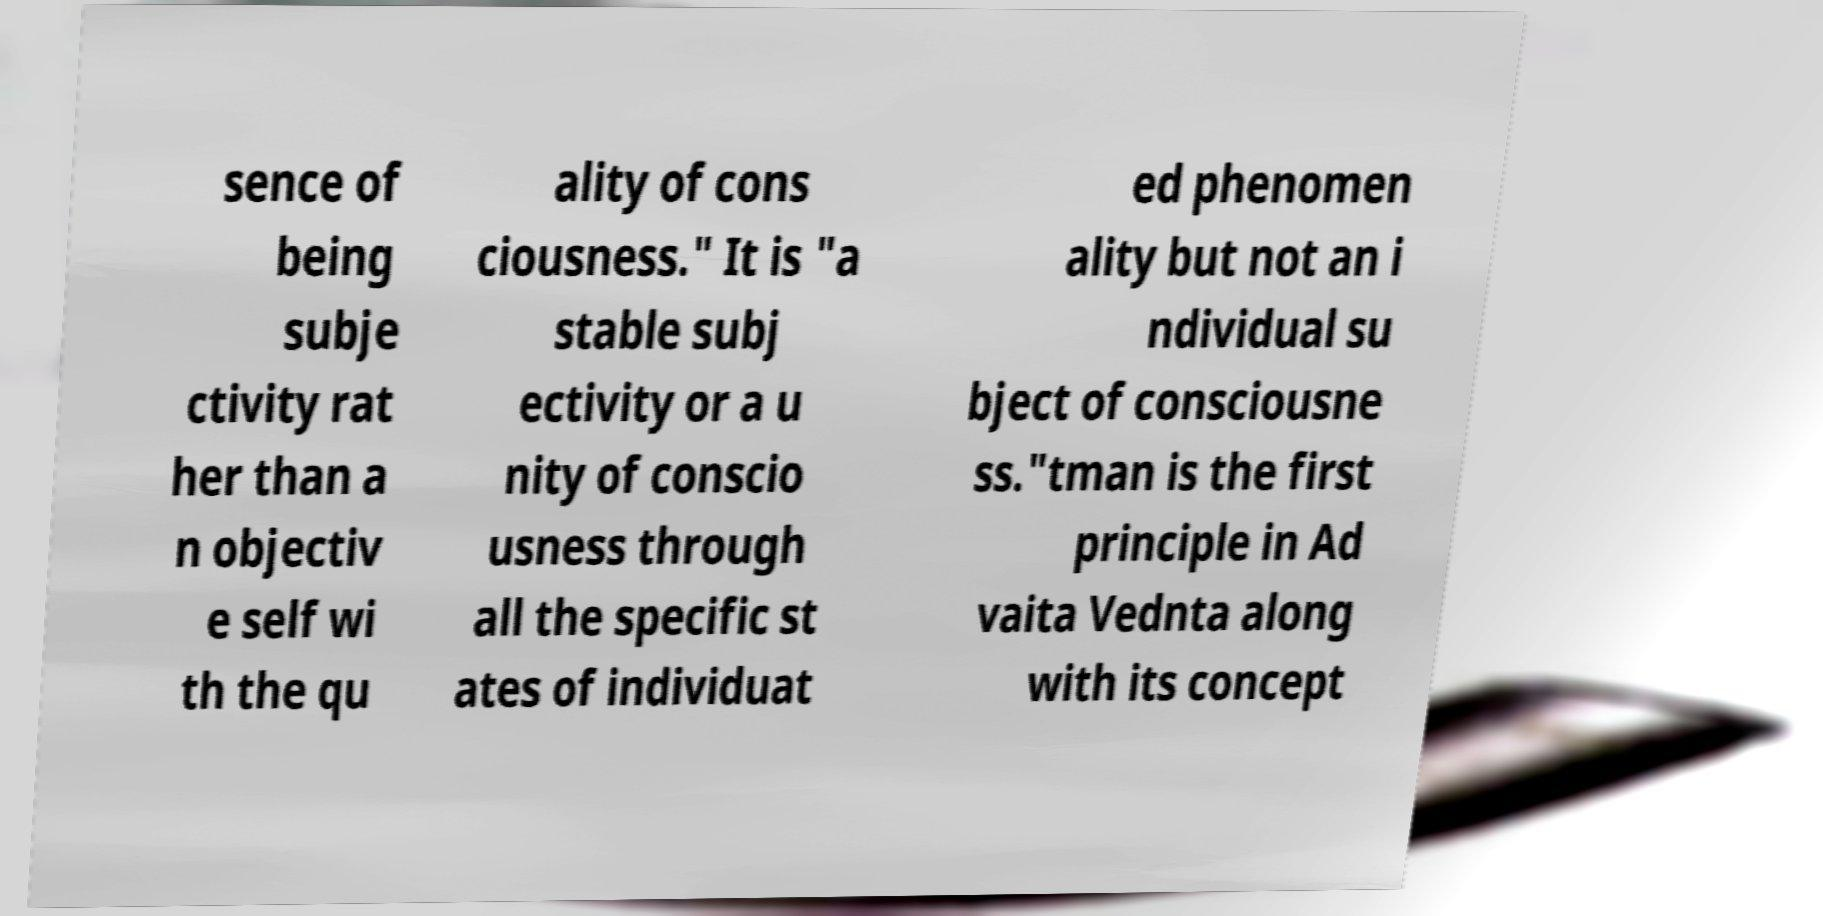Please identify and transcribe the text found in this image. sence of being subje ctivity rat her than a n objectiv e self wi th the qu ality of cons ciousness." It is "a stable subj ectivity or a u nity of conscio usness through all the specific st ates of individuat ed phenomen ality but not an i ndividual su bject of consciousne ss."tman is the first principle in Ad vaita Vednta along with its concept 